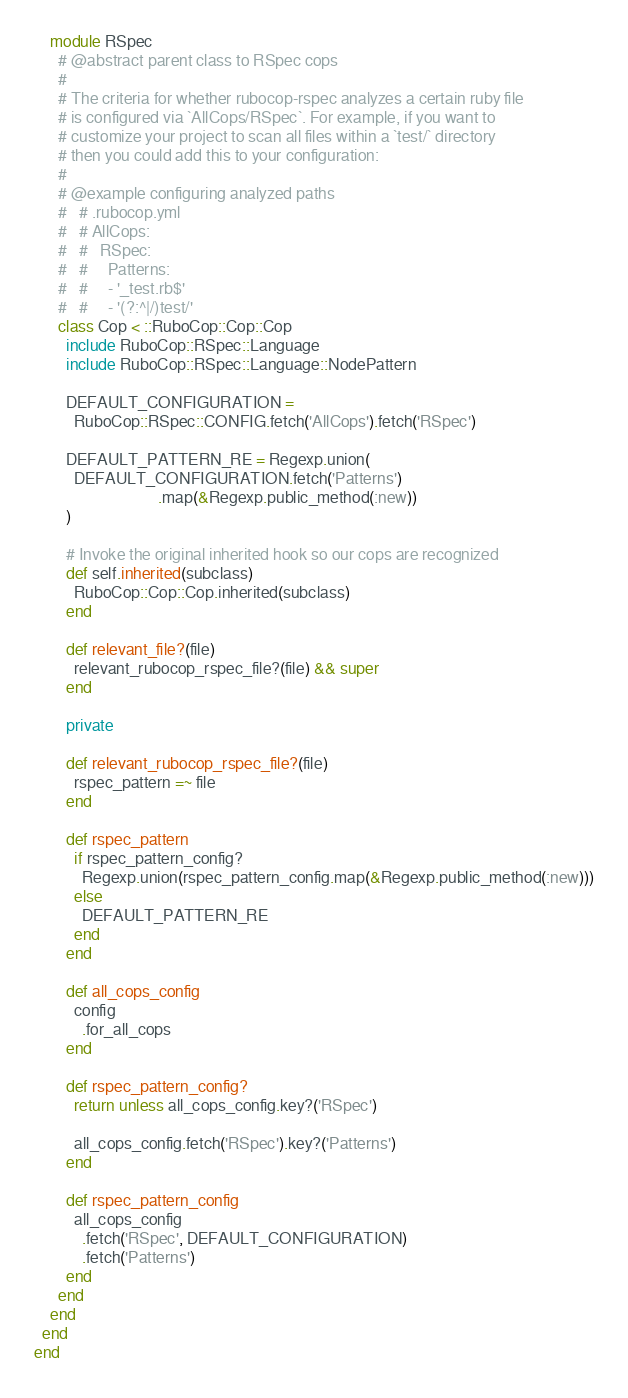<code> <loc_0><loc_0><loc_500><loc_500><_Ruby_>    module RSpec
      # @abstract parent class to RSpec cops
      #
      # The criteria for whether rubocop-rspec analyzes a certain ruby file
      # is configured via `AllCops/RSpec`. For example, if you want to
      # customize your project to scan all files within a `test/` directory
      # then you could add this to your configuration:
      #
      # @example configuring analyzed paths
      #   # .rubocop.yml
      #   # AllCops:
      #   #   RSpec:
      #   #     Patterns:
      #   #     - '_test.rb$'
      #   #     - '(?:^|/)test/'
      class Cop < ::RuboCop::Cop::Cop
        include RuboCop::RSpec::Language
        include RuboCop::RSpec::Language::NodePattern

        DEFAULT_CONFIGURATION =
          RuboCop::RSpec::CONFIG.fetch('AllCops').fetch('RSpec')

        DEFAULT_PATTERN_RE = Regexp.union(
          DEFAULT_CONFIGURATION.fetch('Patterns')
                               .map(&Regexp.public_method(:new))
        )

        # Invoke the original inherited hook so our cops are recognized
        def self.inherited(subclass)
          RuboCop::Cop::Cop.inherited(subclass)
        end

        def relevant_file?(file)
          relevant_rubocop_rspec_file?(file) && super
        end

        private

        def relevant_rubocop_rspec_file?(file)
          rspec_pattern =~ file
        end

        def rspec_pattern
          if rspec_pattern_config?
            Regexp.union(rspec_pattern_config.map(&Regexp.public_method(:new)))
          else
            DEFAULT_PATTERN_RE
          end
        end

        def all_cops_config
          config
            .for_all_cops
        end

        def rspec_pattern_config?
          return unless all_cops_config.key?('RSpec')

          all_cops_config.fetch('RSpec').key?('Patterns')
        end

        def rspec_pattern_config
          all_cops_config
            .fetch('RSpec', DEFAULT_CONFIGURATION)
            .fetch('Patterns')
        end
      end
    end
  end
end
</code> 